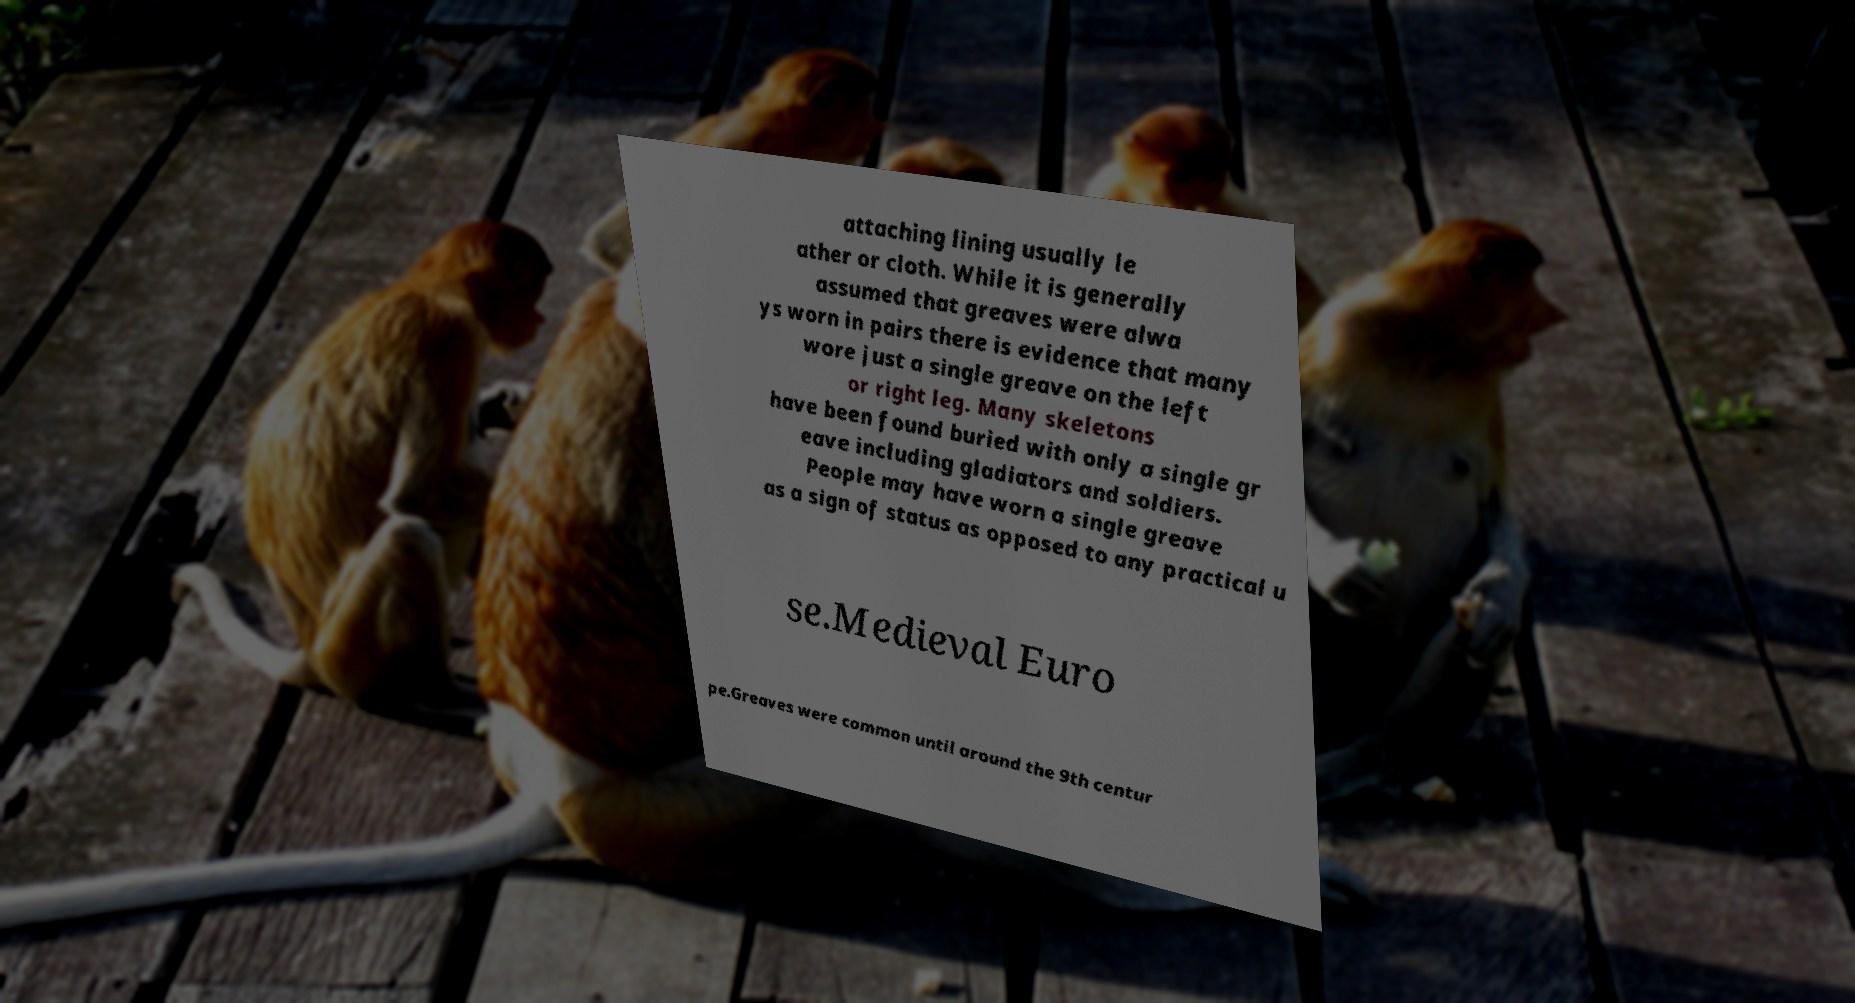Can you read and provide the text displayed in the image?This photo seems to have some interesting text. Can you extract and type it out for me? attaching lining usually le ather or cloth. While it is generally assumed that greaves were alwa ys worn in pairs there is evidence that many wore just a single greave on the left or right leg. Many skeletons have been found buried with only a single gr eave including gladiators and soldiers. People may have worn a single greave as a sign of status as opposed to any practical u se.Medieval Euro pe.Greaves were common until around the 9th centur 